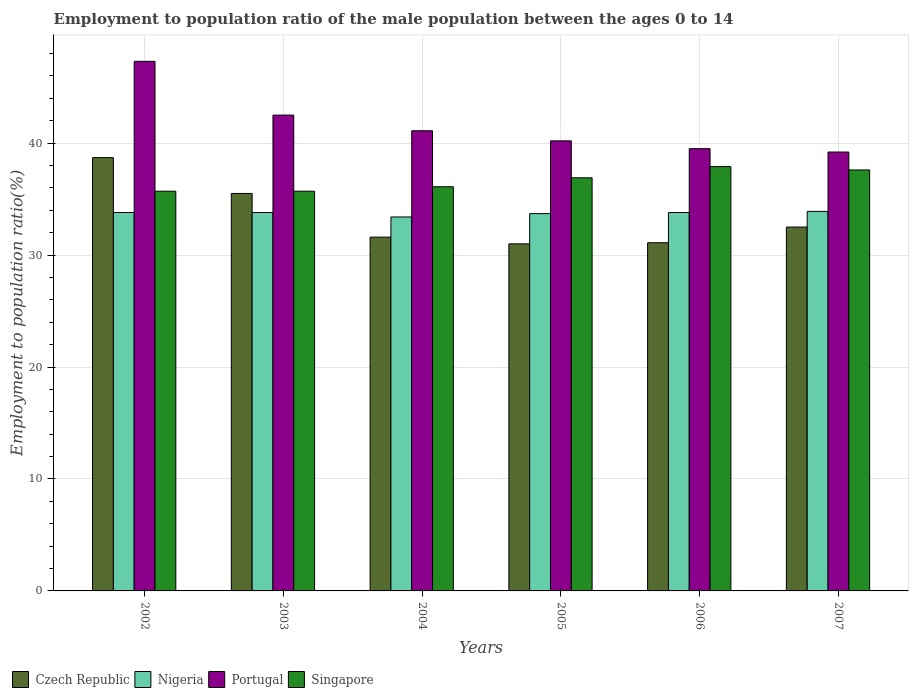How many groups of bars are there?
Give a very brief answer. 6. Are the number of bars on each tick of the X-axis equal?
Provide a short and direct response. Yes. What is the employment to population ratio in Singapore in 2007?
Keep it short and to the point. 37.6. Across all years, what is the maximum employment to population ratio in Czech Republic?
Ensure brevity in your answer.  38.7. In which year was the employment to population ratio in Nigeria minimum?
Your response must be concise. 2004. What is the total employment to population ratio in Portugal in the graph?
Your answer should be compact. 249.8. What is the difference between the employment to population ratio in Czech Republic in 2003 and that in 2004?
Make the answer very short. 3.9. What is the difference between the employment to population ratio in Portugal in 2005 and the employment to population ratio in Nigeria in 2006?
Provide a succinct answer. 6.4. What is the average employment to population ratio in Czech Republic per year?
Offer a terse response. 33.4. In the year 2003, what is the difference between the employment to population ratio in Czech Republic and employment to population ratio in Nigeria?
Offer a terse response. 1.7. In how many years, is the employment to population ratio in Singapore greater than 46 %?
Your answer should be compact. 0. What is the ratio of the employment to population ratio in Portugal in 2002 to that in 2004?
Offer a very short reply. 1.15. Is the employment to population ratio in Portugal in 2005 less than that in 2006?
Offer a terse response. No. Is the difference between the employment to population ratio in Czech Republic in 2002 and 2005 greater than the difference between the employment to population ratio in Nigeria in 2002 and 2005?
Your answer should be compact. Yes. What is the difference between the highest and the second highest employment to population ratio in Portugal?
Your answer should be very brief. 4.8. What is the difference between the highest and the lowest employment to population ratio in Portugal?
Make the answer very short. 8.1. Is it the case that in every year, the sum of the employment to population ratio in Singapore and employment to population ratio in Portugal is greater than the sum of employment to population ratio in Czech Republic and employment to population ratio in Nigeria?
Ensure brevity in your answer.  Yes. What does the 1st bar from the left in 2005 represents?
Give a very brief answer. Czech Republic. What does the 1st bar from the right in 2006 represents?
Your answer should be compact. Singapore. Is it the case that in every year, the sum of the employment to population ratio in Singapore and employment to population ratio in Czech Republic is greater than the employment to population ratio in Portugal?
Your answer should be compact. Yes. How many bars are there?
Provide a succinct answer. 24. Does the graph contain any zero values?
Make the answer very short. No. Does the graph contain grids?
Provide a short and direct response. Yes. Where does the legend appear in the graph?
Keep it short and to the point. Bottom left. How are the legend labels stacked?
Your answer should be compact. Horizontal. What is the title of the graph?
Offer a terse response. Employment to population ratio of the male population between the ages 0 to 14. What is the Employment to population ratio(%) of Czech Republic in 2002?
Provide a short and direct response. 38.7. What is the Employment to population ratio(%) in Nigeria in 2002?
Your response must be concise. 33.8. What is the Employment to population ratio(%) in Portugal in 2002?
Ensure brevity in your answer.  47.3. What is the Employment to population ratio(%) of Singapore in 2002?
Offer a terse response. 35.7. What is the Employment to population ratio(%) of Czech Republic in 2003?
Provide a succinct answer. 35.5. What is the Employment to population ratio(%) of Nigeria in 2003?
Your answer should be compact. 33.8. What is the Employment to population ratio(%) in Portugal in 2003?
Provide a short and direct response. 42.5. What is the Employment to population ratio(%) in Singapore in 2003?
Offer a terse response. 35.7. What is the Employment to population ratio(%) in Czech Republic in 2004?
Your answer should be very brief. 31.6. What is the Employment to population ratio(%) in Nigeria in 2004?
Offer a very short reply. 33.4. What is the Employment to population ratio(%) in Portugal in 2004?
Give a very brief answer. 41.1. What is the Employment to population ratio(%) of Singapore in 2004?
Your response must be concise. 36.1. What is the Employment to population ratio(%) of Nigeria in 2005?
Make the answer very short. 33.7. What is the Employment to population ratio(%) of Portugal in 2005?
Provide a short and direct response. 40.2. What is the Employment to population ratio(%) of Singapore in 2005?
Your answer should be compact. 36.9. What is the Employment to population ratio(%) in Czech Republic in 2006?
Provide a succinct answer. 31.1. What is the Employment to population ratio(%) of Nigeria in 2006?
Make the answer very short. 33.8. What is the Employment to population ratio(%) of Portugal in 2006?
Give a very brief answer. 39.5. What is the Employment to population ratio(%) of Singapore in 2006?
Provide a short and direct response. 37.9. What is the Employment to population ratio(%) of Czech Republic in 2007?
Your response must be concise. 32.5. What is the Employment to population ratio(%) of Nigeria in 2007?
Your answer should be compact. 33.9. What is the Employment to population ratio(%) of Portugal in 2007?
Offer a very short reply. 39.2. What is the Employment to population ratio(%) of Singapore in 2007?
Your answer should be very brief. 37.6. Across all years, what is the maximum Employment to population ratio(%) in Czech Republic?
Your answer should be very brief. 38.7. Across all years, what is the maximum Employment to population ratio(%) in Nigeria?
Provide a succinct answer. 33.9. Across all years, what is the maximum Employment to population ratio(%) in Portugal?
Keep it short and to the point. 47.3. Across all years, what is the maximum Employment to population ratio(%) of Singapore?
Your answer should be compact. 37.9. Across all years, what is the minimum Employment to population ratio(%) of Czech Republic?
Ensure brevity in your answer.  31. Across all years, what is the minimum Employment to population ratio(%) in Nigeria?
Keep it short and to the point. 33.4. Across all years, what is the minimum Employment to population ratio(%) of Portugal?
Provide a succinct answer. 39.2. Across all years, what is the minimum Employment to population ratio(%) of Singapore?
Give a very brief answer. 35.7. What is the total Employment to population ratio(%) in Czech Republic in the graph?
Your answer should be very brief. 200.4. What is the total Employment to population ratio(%) in Nigeria in the graph?
Offer a terse response. 202.4. What is the total Employment to population ratio(%) in Portugal in the graph?
Your response must be concise. 249.8. What is the total Employment to population ratio(%) in Singapore in the graph?
Provide a succinct answer. 219.9. What is the difference between the Employment to population ratio(%) of Czech Republic in 2002 and that in 2003?
Provide a succinct answer. 3.2. What is the difference between the Employment to population ratio(%) of Singapore in 2002 and that in 2003?
Your answer should be compact. 0. What is the difference between the Employment to population ratio(%) of Czech Republic in 2002 and that in 2004?
Your answer should be very brief. 7.1. What is the difference between the Employment to population ratio(%) in Portugal in 2002 and that in 2004?
Offer a terse response. 6.2. What is the difference between the Employment to population ratio(%) in Portugal in 2002 and that in 2005?
Give a very brief answer. 7.1. What is the difference between the Employment to population ratio(%) of Czech Republic in 2002 and that in 2006?
Offer a very short reply. 7.6. What is the difference between the Employment to population ratio(%) in Portugal in 2002 and that in 2006?
Give a very brief answer. 7.8. What is the difference between the Employment to population ratio(%) in Singapore in 2002 and that in 2006?
Offer a very short reply. -2.2. What is the difference between the Employment to population ratio(%) in Nigeria in 2002 and that in 2007?
Provide a succinct answer. -0.1. What is the difference between the Employment to population ratio(%) in Portugal in 2002 and that in 2007?
Offer a very short reply. 8.1. What is the difference between the Employment to population ratio(%) in Singapore in 2002 and that in 2007?
Your response must be concise. -1.9. What is the difference between the Employment to population ratio(%) of Nigeria in 2003 and that in 2004?
Your answer should be compact. 0.4. What is the difference between the Employment to population ratio(%) of Singapore in 2003 and that in 2004?
Keep it short and to the point. -0.4. What is the difference between the Employment to population ratio(%) of Nigeria in 2003 and that in 2005?
Offer a terse response. 0.1. What is the difference between the Employment to population ratio(%) in Portugal in 2003 and that in 2005?
Offer a very short reply. 2.3. What is the difference between the Employment to population ratio(%) in Singapore in 2003 and that in 2005?
Offer a very short reply. -1.2. What is the difference between the Employment to population ratio(%) of Czech Republic in 2003 and that in 2006?
Provide a succinct answer. 4.4. What is the difference between the Employment to population ratio(%) of Nigeria in 2003 and that in 2006?
Your response must be concise. 0. What is the difference between the Employment to population ratio(%) in Portugal in 2003 and that in 2006?
Ensure brevity in your answer.  3. What is the difference between the Employment to population ratio(%) in Czech Republic in 2003 and that in 2007?
Make the answer very short. 3. What is the difference between the Employment to population ratio(%) of Nigeria in 2003 and that in 2007?
Give a very brief answer. -0.1. What is the difference between the Employment to population ratio(%) in Portugal in 2003 and that in 2007?
Provide a short and direct response. 3.3. What is the difference between the Employment to population ratio(%) in Czech Republic in 2004 and that in 2005?
Keep it short and to the point. 0.6. What is the difference between the Employment to population ratio(%) of Nigeria in 2004 and that in 2005?
Offer a terse response. -0.3. What is the difference between the Employment to population ratio(%) of Portugal in 2004 and that in 2005?
Ensure brevity in your answer.  0.9. What is the difference between the Employment to population ratio(%) in Singapore in 2004 and that in 2005?
Offer a very short reply. -0.8. What is the difference between the Employment to population ratio(%) in Portugal in 2004 and that in 2006?
Provide a succinct answer. 1.6. What is the difference between the Employment to population ratio(%) of Czech Republic in 2004 and that in 2007?
Offer a very short reply. -0.9. What is the difference between the Employment to population ratio(%) in Nigeria in 2004 and that in 2007?
Keep it short and to the point. -0.5. What is the difference between the Employment to population ratio(%) of Singapore in 2004 and that in 2007?
Your answer should be compact. -1.5. What is the difference between the Employment to population ratio(%) of Nigeria in 2005 and that in 2006?
Keep it short and to the point. -0.1. What is the difference between the Employment to population ratio(%) of Portugal in 2005 and that in 2006?
Provide a short and direct response. 0.7. What is the difference between the Employment to population ratio(%) in Nigeria in 2005 and that in 2007?
Offer a terse response. -0.2. What is the difference between the Employment to population ratio(%) of Portugal in 2005 and that in 2007?
Your answer should be very brief. 1. What is the difference between the Employment to population ratio(%) in Singapore in 2006 and that in 2007?
Offer a terse response. 0.3. What is the difference between the Employment to population ratio(%) in Czech Republic in 2002 and the Employment to population ratio(%) in Portugal in 2003?
Give a very brief answer. -3.8. What is the difference between the Employment to population ratio(%) in Portugal in 2002 and the Employment to population ratio(%) in Singapore in 2003?
Offer a very short reply. 11.6. What is the difference between the Employment to population ratio(%) of Czech Republic in 2002 and the Employment to population ratio(%) of Portugal in 2004?
Keep it short and to the point. -2.4. What is the difference between the Employment to population ratio(%) of Nigeria in 2002 and the Employment to population ratio(%) of Portugal in 2004?
Provide a short and direct response. -7.3. What is the difference between the Employment to population ratio(%) in Czech Republic in 2002 and the Employment to population ratio(%) in Nigeria in 2005?
Provide a succinct answer. 5. What is the difference between the Employment to population ratio(%) of Nigeria in 2002 and the Employment to population ratio(%) of Singapore in 2005?
Keep it short and to the point. -3.1. What is the difference between the Employment to population ratio(%) of Czech Republic in 2002 and the Employment to population ratio(%) of Nigeria in 2006?
Make the answer very short. 4.9. What is the difference between the Employment to population ratio(%) of Czech Republic in 2002 and the Employment to population ratio(%) of Portugal in 2006?
Provide a short and direct response. -0.8. What is the difference between the Employment to population ratio(%) in Czech Republic in 2002 and the Employment to population ratio(%) in Singapore in 2006?
Offer a terse response. 0.8. What is the difference between the Employment to population ratio(%) in Nigeria in 2002 and the Employment to population ratio(%) in Singapore in 2006?
Keep it short and to the point. -4.1. What is the difference between the Employment to population ratio(%) in Czech Republic in 2002 and the Employment to population ratio(%) in Portugal in 2007?
Your answer should be very brief. -0.5. What is the difference between the Employment to population ratio(%) in Nigeria in 2002 and the Employment to population ratio(%) in Portugal in 2007?
Make the answer very short. -5.4. What is the difference between the Employment to population ratio(%) of Czech Republic in 2003 and the Employment to population ratio(%) of Nigeria in 2004?
Provide a short and direct response. 2.1. What is the difference between the Employment to population ratio(%) of Czech Republic in 2003 and the Employment to population ratio(%) of Portugal in 2004?
Keep it short and to the point. -5.6. What is the difference between the Employment to population ratio(%) in Nigeria in 2003 and the Employment to population ratio(%) in Portugal in 2004?
Your answer should be very brief. -7.3. What is the difference between the Employment to population ratio(%) in Czech Republic in 2003 and the Employment to population ratio(%) in Portugal in 2005?
Your response must be concise. -4.7. What is the difference between the Employment to population ratio(%) in Nigeria in 2003 and the Employment to population ratio(%) in Portugal in 2005?
Provide a short and direct response. -6.4. What is the difference between the Employment to population ratio(%) in Czech Republic in 2003 and the Employment to population ratio(%) in Portugal in 2006?
Keep it short and to the point. -4. What is the difference between the Employment to population ratio(%) of Czech Republic in 2003 and the Employment to population ratio(%) of Singapore in 2006?
Offer a terse response. -2.4. What is the difference between the Employment to population ratio(%) in Nigeria in 2003 and the Employment to population ratio(%) in Portugal in 2006?
Keep it short and to the point. -5.7. What is the difference between the Employment to population ratio(%) in Nigeria in 2003 and the Employment to population ratio(%) in Singapore in 2006?
Ensure brevity in your answer.  -4.1. What is the difference between the Employment to population ratio(%) of Czech Republic in 2003 and the Employment to population ratio(%) of Nigeria in 2007?
Offer a terse response. 1.6. What is the difference between the Employment to population ratio(%) in Czech Republic in 2003 and the Employment to population ratio(%) in Singapore in 2007?
Make the answer very short. -2.1. What is the difference between the Employment to population ratio(%) of Nigeria in 2003 and the Employment to population ratio(%) of Portugal in 2007?
Offer a very short reply. -5.4. What is the difference between the Employment to population ratio(%) of Czech Republic in 2004 and the Employment to population ratio(%) of Nigeria in 2005?
Your answer should be compact. -2.1. What is the difference between the Employment to population ratio(%) of Czech Republic in 2004 and the Employment to population ratio(%) of Portugal in 2005?
Offer a terse response. -8.6. What is the difference between the Employment to population ratio(%) of Nigeria in 2004 and the Employment to population ratio(%) of Singapore in 2005?
Offer a terse response. -3.5. What is the difference between the Employment to population ratio(%) of Czech Republic in 2004 and the Employment to population ratio(%) of Portugal in 2006?
Provide a short and direct response. -7.9. What is the difference between the Employment to population ratio(%) of Portugal in 2004 and the Employment to population ratio(%) of Singapore in 2006?
Give a very brief answer. 3.2. What is the difference between the Employment to population ratio(%) of Czech Republic in 2004 and the Employment to population ratio(%) of Nigeria in 2007?
Your answer should be very brief. -2.3. What is the difference between the Employment to population ratio(%) in Nigeria in 2004 and the Employment to population ratio(%) in Singapore in 2007?
Give a very brief answer. -4.2. What is the difference between the Employment to population ratio(%) in Czech Republic in 2005 and the Employment to population ratio(%) in Nigeria in 2006?
Provide a short and direct response. -2.8. What is the difference between the Employment to population ratio(%) in Czech Republic in 2005 and the Employment to population ratio(%) in Singapore in 2006?
Offer a very short reply. -6.9. What is the difference between the Employment to population ratio(%) in Nigeria in 2005 and the Employment to population ratio(%) in Portugal in 2006?
Ensure brevity in your answer.  -5.8. What is the difference between the Employment to population ratio(%) of Nigeria in 2005 and the Employment to population ratio(%) of Singapore in 2006?
Keep it short and to the point. -4.2. What is the difference between the Employment to population ratio(%) of Portugal in 2005 and the Employment to population ratio(%) of Singapore in 2006?
Make the answer very short. 2.3. What is the difference between the Employment to population ratio(%) in Czech Republic in 2005 and the Employment to population ratio(%) in Portugal in 2007?
Ensure brevity in your answer.  -8.2. What is the difference between the Employment to population ratio(%) in Nigeria in 2005 and the Employment to population ratio(%) in Portugal in 2007?
Provide a short and direct response. -5.5. What is the difference between the Employment to population ratio(%) in Czech Republic in 2006 and the Employment to population ratio(%) in Nigeria in 2007?
Ensure brevity in your answer.  -2.8. What is the difference between the Employment to population ratio(%) of Czech Republic in 2006 and the Employment to population ratio(%) of Portugal in 2007?
Provide a succinct answer. -8.1. What is the difference between the Employment to population ratio(%) of Czech Republic in 2006 and the Employment to population ratio(%) of Singapore in 2007?
Offer a terse response. -6.5. What is the difference between the Employment to population ratio(%) of Nigeria in 2006 and the Employment to population ratio(%) of Portugal in 2007?
Provide a short and direct response. -5.4. What is the difference between the Employment to population ratio(%) in Nigeria in 2006 and the Employment to population ratio(%) in Singapore in 2007?
Ensure brevity in your answer.  -3.8. What is the difference between the Employment to population ratio(%) in Portugal in 2006 and the Employment to population ratio(%) in Singapore in 2007?
Keep it short and to the point. 1.9. What is the average Employment to population ratio(%) in Czech Republic per year?
Make the answer very short. 33.4. What is the average Employment to population ratio(%) of Nigeria per year?
Provide a short and direct response. 33.73. What is the average Employment to population ratio(%) of Portugal per year?
Give a very brief answer. 41.63. What is the average Employment to population ratio(%) in Singapore per year?
Offer a terse response. 36.65. In the year 2002, what is the difference between the Employment to population ratio(%) in Czech Republic and Employment to population ratio(%) in Nigeria?
Offer a terse response. 4.9. In the year 2002, what is the difference between the Employment to population ratio(%) in Nigeria and Employment to population ratio(%) in Singapore?
Your answer should be compact. -1.9. In the year 2003, what is the difference between the Employment to population ratio(%) in Czech Republic and Employment to population ratio(%) in Portugal?
Your response must be concise. -7. In the year 2003, what is the difference between the Employment to population ratio(%) in Czech Republic and Employment to population ratio(%) in Singapore?
Provide a succinct answer. -0.2. In the year 2003, what is the difference between the Employment to population ratio(%) of Nigeria and Employment to population ratio(%) of Portugal?
Ensure brevity in your answer.  -8.7. In the year 2003, what is the difference between the Employment to population ratio(%) in Portugal and Employment to population ratio(%) in Singapore?
Keep it short and to the point. 6.8. In the year 2004, what is the difference between the Employment to population ratio(%) of Czech Republic and Employment to population ratio(%) of Nigeria?
Offer a terse response. -1.8. In the year 2004, what is the difference between the Employment to population ratio(%) in Czech Republic and Employment to population ratio(%) in Portugal?
Ensure brevity in your answer.  -9.5. In the year 2004, what is the difference between the Employment to population ratio(%) of Czech Republic and Employment to population ratio(%) of Singapore?
Ensure brevity in your answer.  -4.5. In the year 2004, what is the difference between the Employment to population ratio(%) of Nigeria and Employment to population ratio(%) of Singapore?
Make the answer very short. -2.7. In the year 2005, what is the difference between the Employment to population ratio(%) in Nigeria and Employment to population ratio(%) in Portugal?
Offer a terse response. -6.5. In the year 2005, what is the difference between the Employment to population ratio(%) in Nigeria and Employment to population ratio(%) in Singapore?
Provide a short and direct response. -3.2. In the year 2005, what is the difference between the Employment to population ratio(%) of Portugal and Employment to population ratio(%) of Singapore?
Your answer should be very brief. 3.3. In the year 2006, what is the difference between the Employment to population ratio(%) of Czech Republic and Employment to population ratio(%) of Nigeria?
Make the answer very short. -2.7. In the year 2006, what is the difference between the Employment to population ratio(%) in Czech Republic and Employment to population ratio(%) in Portugal?
Make the answer very short. -8.4. In the year 2006, what is the difference between the Employment to population ratio(%) in Czech Republic and Employment to population ratio(%) in Singapore?
Provide a succinct answer. -6.8. In the year 2007, what is the difference between the Employment to population ratio(%) in Czech Republic and Employment to population ratio(%) in Portugal?
Your response must be concise. -6.7. In the year 2007, what is the difference between the Employment to population ratio(%) in Nigeria and Employment to population ratio(%) in Portugal?
Provide a short and direct response. -5.3. In the year 2007, what is the difference between the Employment to population ratio(%) in Portugal and Employment to population ratio(%) in Singapore?
Provide a succinct answer. 1.6. What is the ratio of the Employment to population ratio(%) in Czech Republic in 2002 to that in 2003?
Ensure brevity in your answer.  1.09. What is the ratio of the Employment to population ratio(%) in Nigeria in 2002 to that in 2003?
Your answer should be compact. 1. What is the ratio of the Employment to population ratio(%) of Portugal in 2002 to that in 2003?
Provide a short and direct response. 1.11. What is the ratio of the Employment to population ratio(%) in Singapore in 2002 to that in 2003?
Provide a short and direct response. 1. What is the ratio of the Employment to population ratio(%) in Czech Republic in 2002 to that in 2004?
Your answer should be very brief. 1.22. What is the ratio of the Employment to population ratio(%) of Nigeria in 2002 to that in 2004?
Your answer should be very brief. 1.01. What is the ratio of the Employment to population ratio(%) in Portugal in 2002 to that in 2004?
Your answer should be compact. 1.15. What is the ratio of the Employment to population ratio(%) in Singapore in 2002 to that in 2004?
Offer a very short reply. 0.99. What is the ratio of the Employment to population ratio(%) of Czech Republic in 2002 to that in 2005?
Offer a terse response. 1.25. What is the ratio of the Employment to population ratio(%) of Nigeria in 2002 to that in 2005?
Your response must be concise. 1. What is the ratio of the Employment to population ratio(%) of Portugal in 2002 to that in 2005?
Provide a short and direct response. 1.18. What is the ratio of the Employment to population ratio(%) in Singapore in 2002 to that in 2005?
Make the answer very short. 0.97. What is the ratio of the Employment to population ratio(%) of Czech Republic in 2002 to that in 2006?
Your response must be concise. 1.24. What is the ratio of the Employment to population ratio(%) of Nigeria in 2002 to that in 2006?
Offer a terse response. 1. What is the ratio of the Employment to population ratio(%) of Portugal in 2002 to that in 2006?
Your answer should be very brief. 1.2. What is the ratio of the Employment to population ratio(%) of Singapore in 2002 to that in 2006?
Provide a short and direct response. 0.94. What is the ratio of the Employment to population ratio(%) in Czech Republic in 2002 to that in 2007?
Give a very brief answer. 1.19. What is the ratio of the Employment to population ratio(%) in Nigeria in 2002 to that in 2007?
Give a very brief answer. 1. What is the ratio of the Employment to population ratio(%) of Portugal in 2002 to that in 2007?
Ensure brevity in your answer.  1.21. What is the ratio of the Employment to population ratio(%) of Singapore in 2002 to that in 2007?
Your response must be concise. 0.95. What is the ratio of the Employment to population ratio(%) in Czech Republic in 2003 to that in 2004?
Keep it short and to the point. 1.12. What is the ratio of the Employment to population ratio(%) of Portugal in 2003 to that in 2004?
Provide a short and direct response. 1.03. What is the ratio of the Employment to population ratio(%) of Singapore in 2003 to that in 2004?
Keep it short and to the point. 0.99. What is the ratio of the Employment to population ratio(%) in Czech Republic in 2003 to that in 2005?
Give a very brief answer. 1.15. What is the ratio of the Employment to population ratio(%) in Nigeria in 2003 to that in 2005?
Offer a terse response. 1. What is the ratio of the Employment to population ratio(%) in Portugal in 2003 to that in 2005?
Provide a succinct answer. 1.06. What is the ratio of the Employment to population ratio(%) in Singapore in 2003 to that in 2005?
Your answer should be compact. 0.97. What is the ratio of the Employment to population ratio(%) in Czech Republic in 2003 to that in 2006?
Keep it short and to the point. 1.14. What is the ratio of the Employment to population ratio(%) in Portugal in 2003 to that in 2006?
Your response must be concise. 1.08. What is the ratio of the Employment to population ratio(%) in Singapore in 2003 to that in 2006?
Keep it short and to the point. 0.94. What is the ratio of the Employment to population ratio(%) in Czech Republic in 2003 to that in 2007?
Your answer should be very brief. 1.09. What is the ratio of the Employment to population ratio(%) in Portugal in 2003 to that in 2007?
Provide a short and direct response. 1.08. What is the ratio of the Employment to population ratio(%) of Singapore in 2003 to that in 2007?
Your answer should be compact. 0.95. What is the ratio of the Employment to population ratio(%) of Czech Republic in 2004 to that in 2005?
Offer a terse response. 1.02. What is the ratio of the Employment to population ratio(%) in Nigeria in 2004 to that in 2005?
Ensure brevity in your answer.  0.99. What is the ratio of the Employment to population ratio(%) in Portugal in 2004 to that in 2005?
Offer a very short reply. 1.02. What is the ratio of the Employment to population ratio(%) in Singapore in 2004 to that in 2005?
Give a very brief answer. 0.98. What is the ratio of the Employment to population ratio(%) in Czech Republic in 2004 to that in 2006?
Your answer should be very brief. 1.02. What is the ratio of the Employment to population ratio(%) in Portugal in 2004 to that in 2006?
Your answer should be very brief. 1.04. What is the ratio of the Employment to population ratio(%) in Singapore in 2004 to that in 2006?
Keep it short and to the point. 0.95. What is the ratio of the Employment to population ratio(%) in Czech Republic in 2004 to that in 2007?
Provide a succinct answer. 0.97. What is the ratio of the Employment to population ratio(%) in Portugal in 2004 to that in 2007?
Keep it short and to the point. 1.05. What is the ratio of the Employment to population ratio(%) of Singapore in 2004 to that in 2007?
Your response must be concise. 0.96. What is the ratio of the Employment to population ratio(%) of Czech Republic in 2005 to that in 2006?
Your answer should be very brief. 1. What is the ratio of the Employment to population ratio(%) of Portugal in 2005 to that in 2006?
Your answer should be compact. 1.02. What is the ratio of the Employment to population ratio(%) of Singapore in 2005 to that in 2006?
Your response must be concise. 0.97. What is the ratio of the Employment to population ratio(%) of Czech Republic in 2005 to that in 2007?
Your answer should be very brief. 0.95. What is the ratio of the Employment to population ratio(%) of Portugal in 2005 to that in 2007?
Ensure brevity in your answer.  1.03. What is the ratio of the Employment to population ratio(%) in Singapore in 2005 to that in 2007?
Provide a short and direct response. 0.98. What is the ratio of the Employment to population ratio(%) in Czech Republic in 2006 to that in 2007?
Offer a very short reply. 0.96. What is the ratio of the Employment to population ratio(%) of Portugal in 2006 to that in 2007?
Offer a very short reply. 1.01. What is the difference between the highest and the second highest Employment to population ratio(%) in Czech Republic?
Provide a succinct answer. 3.2. What is the difference between the highest and the lowest Employment to population ratio(%) in Czech Republic?
Provide a succinct answer. 7.7. What is the difference between the highest and the lowest Employment to population ratio(%) in Nigeria?
Ensure brevity in your answer.  0.5. What is the difference between the highest and the lowest Employment to population ratio(%) in Portugal?
Your answer should be compact. 8.1. 